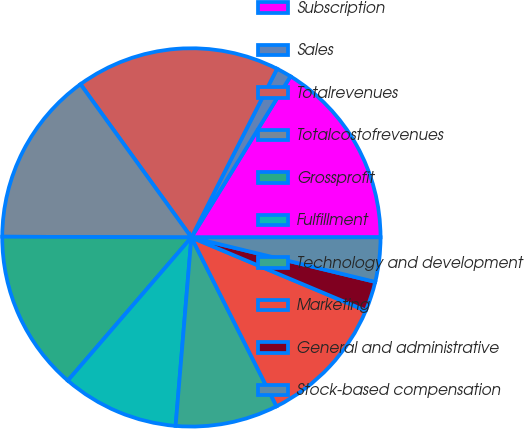Convert chart to OTSL. <chart><loc_0><loc_0><loc_500><loc_500><pie_chart><fcel>Subscription<fcel>Sales<fcel>Totalrevenues<fcel>Totalcostofrevenues<fcel>Grossprofit<fcel>Fulfillment<fcel>Technology and development<fcel>Marketing<fcel>General and administrative<fcel>Stock-based compensation<nl><fcel>16.21%<fcel>1.3%<fcel>17.45%<fcel>14.97%<fcel>13.73%<fcel>10.0%<fcel>8.76%<fcel>11.24%<fcel>2.55%<fcel>3.79%<nl></chart> 